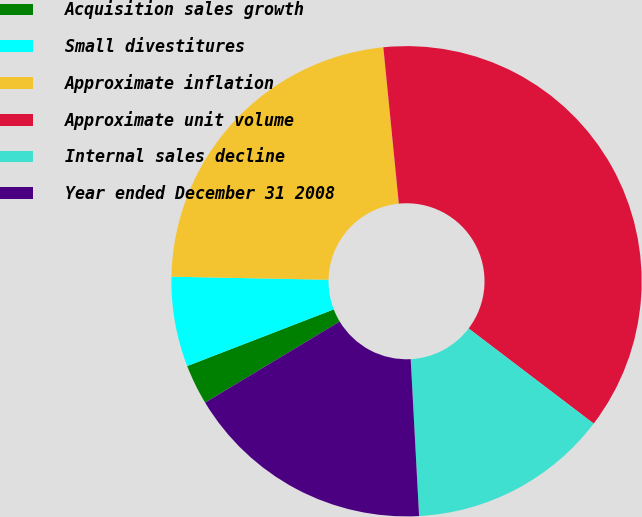Convert chart. <chart><loc_0><loc_0><loc_500><loc_500><pie_chart><fcel>Acquisition sales growth<fcel>Small divestitures<fcel>Approximate inflation<fcel>Approximate unit volume<fcel>Internal sales decline<fcel>Year ended December 31 2008<nl><fcel>2.76%<fcel>6.18%<fcel>23.12%<fcel>36.92%<fcel>13.8%<fcel>17.22%<nl></chart> 